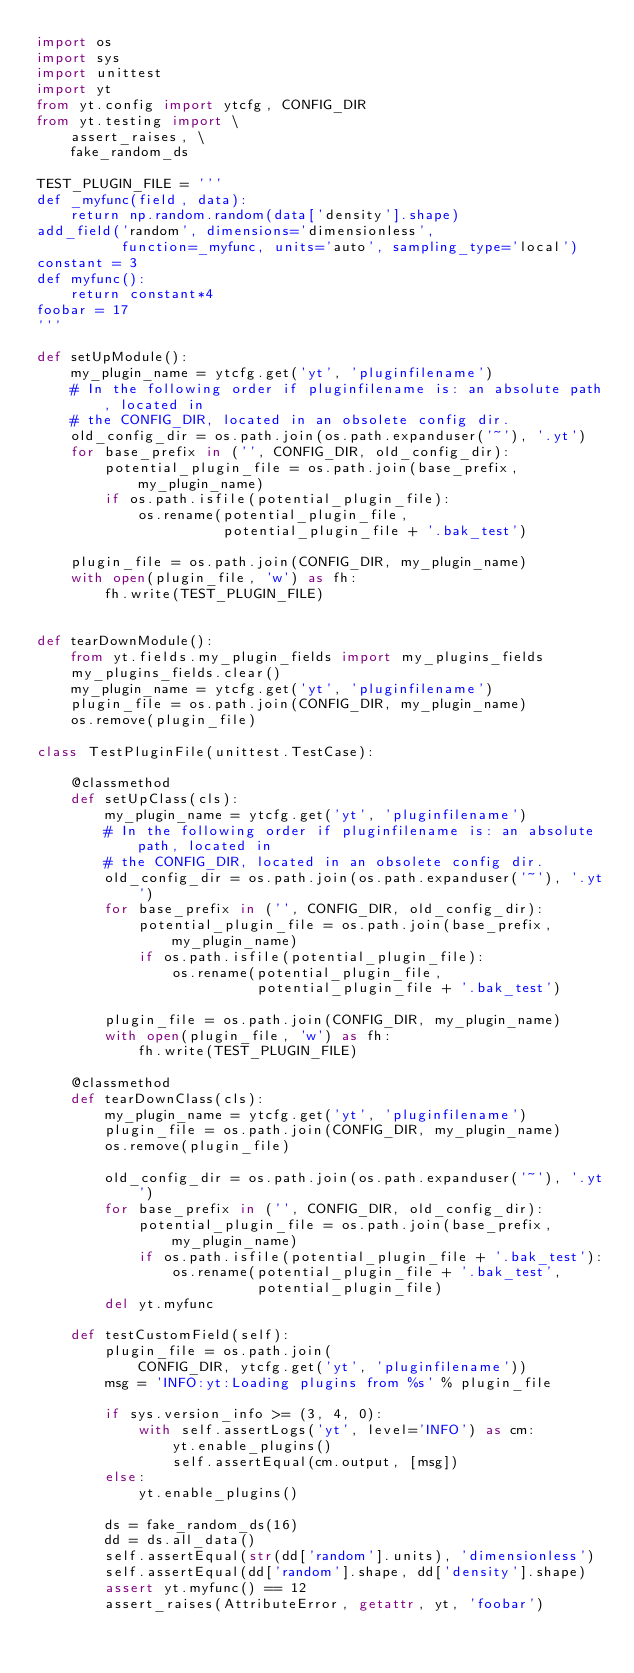Convert code to text. <code><loc_0><loc_0><loc_500><loc_500><_Python_>import os
import sys
import unittest
import yt
from yt.config import ytcfg, CONFIG_DIR
from yt.testing import \
    assert_raises, \
    fake_random_ds

TEST_PLUGIN_FILE = '''
def _myfunc(field, data):
    return np.random.random(data['density'].shape)
add_field('random', dimensions='dimensionless',
          function=_myfunc, units='auto', sampling_type='local')
constant = 3
def myfunc():
    return constant*4
foobar = 17
'''

def setUpModule():
    my_plugin_name = ytcfg.get('yt', 'pluginfilename')
    # In the following order if pluginfilename is: an absolute path, located in
    # the CONFIG_DIR, located in an obsolete config dir.
    old_config_dir = os.path.join(os.path.expanduser('~'), '.yt')
    for base_prefix in ('', CONFIG_DIR, old_config_dir):
        potential_plugin_file = os.path.join(base_prefix, my_plugin_name)
        if os.path.isfile(potential_plugin_file):
            os.rename(potential_plugin_file,
                      potential_plugin_file + '.bak_test')

    plugin_file = os.path.join(CONFIG_DIR, my_plugin_name)
    with open(plugin_file, 'w') as fh:
        fh.write(TEST_PLUGIN_FILE)


def tearDownModule():
    from yt.fields.my_plugin_fields import my_plugins_fields
    my_plugins_fields.clear()
    my_plugin_name = ytcfg.get('yt', 'pluginfilename')
    plugin_file = os.path.join(CONFIG_DIR, my_plugin_name)
    os.remove(plugin_file)

class TestPluginFile(unittest.TestCase):

    @classmethod
    def setUpClass(cls):
        my_plugin_name = ytcfg.get('yt', 'pluginfilename')
        # In the following order if pluginfilename is: an absolute path, located in
        # the CONFIG_DIR, located in an obsolete config dir.
        old_config_dir = os.path.join(os.path.expanduser('~'), '.yt')
        for base_prefix in ('', CONFIG_DIR, old_config_dir):
            potential_plugin_file = os.path.join(base_prefix, my_plugin_name)
            if os.path.isfile(potential_plugin_file):
                os.rename(potential_plugin_file,
                          potential_plugin_file + '.bak_test')

        plugin_file = os.path.join(CONFIG_DIR, my_plugin_name)
        with open(plugin_file, 'w') as fh:
            fh.write(TEST_PLUGIN_FILE)

    @classmethod
    def tearDownClass(cls):
        my_plugin_name = ytcfg.get('yt', 'pluginfilename')
        plugin_file = os.path.join(CONFIG_DIR, my_plugin_name)
        os.remove(plugin_file)

        old_config_dir = os.path.join(os.path.expanduser('~'), '.yt')
        for base_prefix in ('', CONFIG_DIR, old_config_dir):
            potential_plugin_file = os.path.join(base_prefix, my_plugin_name)
            if os.path.isfile(potential_plugin_file + '.bak_test'):
                os.rename(potential_plugin_file + '.bak_test',
                          potential_plugin_file)
        del yt.myfunc

    def testCustomField(self):
        plugin_file = os.path.join(
            CONFIG_DIR, ytcfg.get('yt', 'pluginfilename'))
        msg = 'INFO:yt:Loading plugins from %s' % plugin_file

        if sys.version_info >= (3, 4, 0):
            with self.assertLogs('yt', level='INFO') as cm:
                yt.enable_plugins()
                self.assertEqual(cm.output, [msg])
        else:
            yt.enable_plugins()

        ds = fake_random_ds(16)
        dd = ds.all_data()
        self.assertEqual(str(dd['random'].units), 'dimensionless')
        self.assertEqual(dd['random'].shape, dd['density'].shape)
        assert yt.myfunc() == 12
        assert_raises(AttributeError, getattr, yt, 'foobar')
</code> 